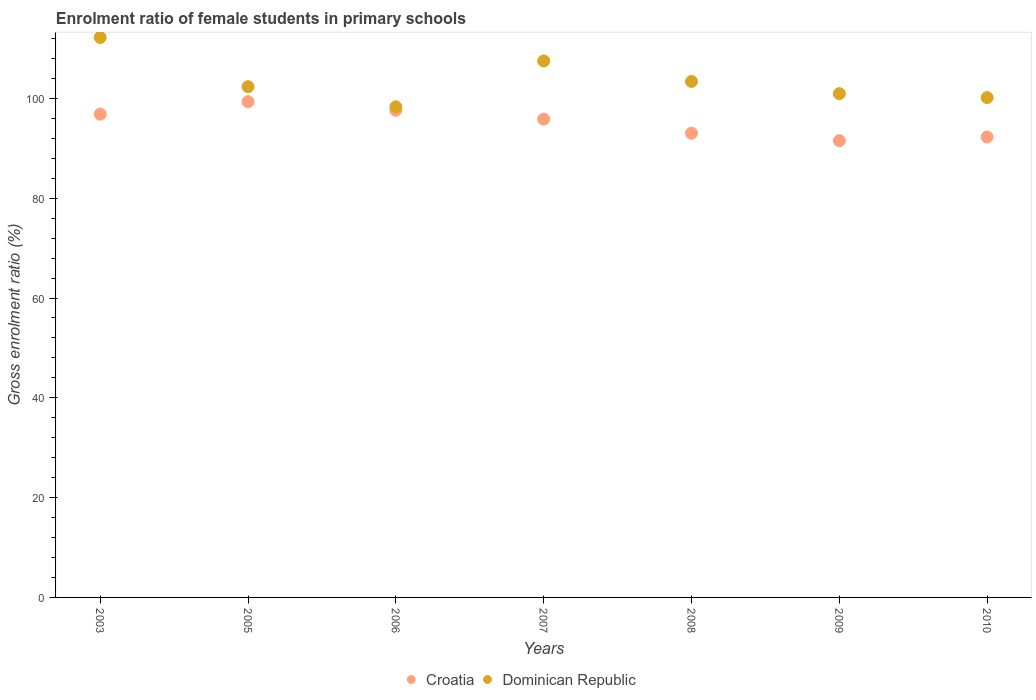Is the number of dotlines equal to the number of legend labels?
Keep it short and to the point. Yes. What is the enrolment ratio of female students in primary schools in Croatia in 2005?
Your response must be concise. 99.34. Across all years, what is the maximum enrolment ratio of female students in primary schools in Dominican Republic?
Your answer should be very brief. 112.22. Across all years, what is the minimum enrolment ratio of female students in primary schools in Dominican Republic?
Your response must be concise. 98.31. What is the total enrolment ratio of female students in primary schools in Croatia in the graph?
Provide a succinct answer. 666.46. What is the difference between the enrolment ratio of female students in primary schools in Dominican Republic in 2006 and that in 2009?
Your response must be concise. -2.64. What is the difference between the enrolment ratio of female students in primary schools in Dominican Republic in 2006 and the enrolment ratio of female students in primary schools in Croatia in 2008?
Make the answer very short. 5.29. What is the average enrolment ratio of female students in primary schools in Dominican Republic per year?
Provide a short and direct response. 103.55. In the year 2007, what is the difference between the enrolment ratio of female students in primary schools in Dominican Republic and enrolment ratio of female students in primary schools in Croatia?
Provide a succinct answer. 11.66. What is the ratio of the enrolment ratio of female students in primary schools in Dominican Republic in 2005 to that in 2006?
Your answer should be compact. 1.04. What is the difference between the highest and the second highest enrolment ratio of female students in primary schools in Croatia?
Give a very brief answer. 1.73. What is the difference between the highest and the lowest enrolment ratio of female students in primary schools in Dominican Republic?
Keep it short and to the point. 13.91. Is the sum of the enrolment ratio of female students in primary schools in Dominican Republic in 2003 and 2006 greater than the maximum enrolment ratio of female students in primary schools in Croatia across all years?
Provide a short and direct response. Yes. Is the enrolment ratio of female students in primary schools in Croatia strictly greater than the enrolment ratio of female students in primary schools in Dominican Republic over the years?
Give a very brief answer. No. Is the enrolment ratio of female students in primary schools in Croatia strictly less than the enrolment ratio of female students in primary schools in Dominican Republic over the years?
Your response must be concise. Yes. How many dotlines are there?
Your response must be concise. 2. Are the values on the major ticks of Y-axis written in scientific E-notation?
Ensure brevity in your answer.  No. Does the graph contain grids?
Provide a short and direct response. No. Where does the legend appear in the graph?
Offer a very short reply. Bottom center. What is the title of the graph?
Provide a succinct answer. Enrolment ratio of female students in primary schools. Does "West Bank and Gaza" appear as one of the legend labels in the graph?
Ensure brevity in your answer.  No. What is the Gross enrolment ratio (%) in Croatia in 2003?
Keep it short and to the point. 96.85. What is the Gross enrolment ratio (%) in Dominican Republic in 2003?
Provide a succinct answer. 112.22. What is the Gross enrolment ratio (%) of Croatia in 2005?
Offer a terse response. 99.34. What is the Gross enrolment ratio (%) of Dominican Republic in 2005?
Make the answer very short. 102.34. What is the Gross enrolment ratio (%) of Croatia in 2006?
Keep it short and to the point. 97.62. What is the Gross enrolment ratio (%) in Dominican Republic in 2006?
Give a very brief answer. 98.31. What is the Gross enrolment ratio (%) in Croatia in 2007?
Your answer should be compact. 95.84. What is the Gross enrolment ratio (%) in Dominican Republic in 2007?
Your answer should be very brief. 107.5. What is the Gross enrolment ratio (%) in Croatia in 2008?
Keep it short and to the point. 93.02. What is the Gross enrolment ratio (%) in Dominican Republic in 2008?
Ensure brevity in your answer.  103.39. What is the Gross enrolment ratio (%) in Croatia in 2009?
Provide a succinct answer. 91.52. What is the Gross enrolment ratio (%) of Dominican Republic in 2009?
Offer a very short reply. 100.95. What is the Gross enrolment ratio (%) in Croatia in 2010?
Your answer should be very brief. 92.26. What is the Gross enrolment ratio (%) in Dominican Republic in 2010?
Offer a very short reply. 100.16. Across all years, what is the maximum Gross enrolment ratio (%) in Croatia?
Provide a succinct answer. 99.34. Across all years, what is the maximum Gross enrolment ratio (%) in Dominican Republic?
Offer a very short reply. 112.22. Across all years, what is the minimum Gross enrolment ratio (%) of Croatia?
Give a very brief answer. 91.52. Across all years, what is the minimum Gross enrolment ratio (%) in Dominican Republic?
Keep it short and to the point. 98.31. What is the total Gross enrolment ratio (%) in Croatia in the graph?
Provide a succinct answer. 666.46. What is the total Gross enrolment ratio (%) in Dominican Republic in the graph?
Provide a succinct answer. 724.87. What is the difference between the Gross enrolment ratio (%) of Croatia in 2003 and that in 2005?
Give a very brief answer. -2.5. What is the difference between the Gross enrolment ratio (%) in Dominican Republic in 2003 and that in 2005?
Make the answer very short. 9.87. What is the difference between the Gross enrolment ratio (%) in Croatia in 2003 and that in 2006?
Your answer should be very brief. -0.77. What is the difference between the Gross enrolment ratio (%) in Dominican Republic in 2003 and that in 2006?
Keep it short and to the point. 13.91. What is the difference between the Gross enrolment ratio (%) of Croatia in 2003 and that in 2007?
Provide a short and direct response. 1. What is the difference between the Gross enrolment ratio (%) of Dominican Republic in 2003 and that in 2007?
Your response must be concise. 4.71. What is the difference between the Gross enrolment ratio (%) of Croatia in 2003 and that in 2008?
Your answer should be very brief. 3.82. What is the difference between the Gross enrolment ratio (%) of Dominican Republic in 2003 and that in 2008?
Give a very brief answer. 8.83. What is the difference between the Gross enrolment ratio (%) in Croatia in 2003 and that in 2009?
Give a very brief answer. 5.32. What is the difference between the Gross enrolment ratio (%) of Dominican Republic in 2003 and that in 2009?
Your answer should be very brief. 11.27. What is the difference between the Gross enrolment ratio (%) in Croatia in 2003 and that in 2010?
Your response must be concise. 4.58. What is the difference between the Gross enrolment ratio (%) in Dominican Republic in 2003 and that in 2010?
Your answer should be compact. 12.06. What is the difference between the Gross enrolment ratio (%) in Croatia in 2005 and that in 2006?
Offer a terse response. 1.73. What is the difference between the Gross enrolment ratio (%) of Dominican Republic in 2005 and that in 2006?
Make the answer very short. 4.04. What is the difference between the Gross enrolment ratio (%) of Croatia in 2005 and that in 2007?
Give a very brief answer. 3.5. What is the difference between the Gross enrolment ratio (%) in Dominican Republic in 2005 and that in 2007?
Provide a short and direct response. -5.16. What is the difference between the Gross enrolment ratio (%) of Croatia in 2005 and that in 2008?
Keep it short and to the point. 6.32. What is the difference between the Gross enrolment ratio (%) of Dominican Republic in 2005 and that in 2008?
Give a very brief answer. -1.04. What is the difference between the Gross enrolment ratio (%) of Croatia in 2005 and that in 2009?
Keep it short and to the point. 7.82. What is the difference between the Gross enrolment ratio (%) of Dominican Republic in 2005 and that in 2009?
Ensure brevity in your answer.  1.4. What is the difference between the Gross enrolment ratio (%) of Croatia in 2005 and that in 2010?
Keep it short and to the point. 7.08. What is the difference between the Gross enrolment ratio (%) in Dominican Republic in 2005 and that in 2010?
Offer a very short reply. 2.18. What is the difference between the Gross enrolment ratio (%) in Croatia in 2006 and that in 2007?
Provide a short and direct response. 1.77. What is the difference between the Gross enrolment ratio (%) of Dominican Republic in 2006 and that in 2007?
Make the answer very short. -9.2. What is the difference between the Gross enrolment ratio (%) in Croatia in 2006 and that in 2008?
Your answer should be compact. 4.6. What is the difference between the Gross enrolment ratio (%) of Dominican Republic in 2006 and that in 2008?
Your response must be concise. -5.08. What is the difference between the Gross enrolment ratio (%) of Croatia in 2006 and that in 2009?
Your response must be concise. 6.1. What is the difference between the Gross enrolment ratio (%) of Dominican Republic in 2006 and that in 2009?
Provide a succinct answer. -2.64. What is the difference between the Gross enrolment ratio (%) in Croatia in 2006 and that in 2010?
Offer a very short reply. 5.36. What is the difference between the Gross enrolment ratio (%) of Dominican Republic in 2006 and that in 2010?
Provide a succinct answer. -1.85. What is the difference between the Gross enrolment ratio (%) of Croatia in 2007 and that in 2008?
Your answer should be very brief. 2.82. What is the difference between the Gross enrolment ratio (%) of Dominican Republic in 2007 and that in 2008?
Provide a short and direct response. 4.11. What is the difference between the Gross enrolment ratio (%) in Croatia in 2007 and that in 2009?
Make the answer very short. 4.32. What is the difference between the Gross enrolment ratio (%) in Dominican Republic in 2007 and that in 2009?
Make the answer very short. 6.56. What is the difference between the Gross enrolment ratio (%) of Croatia in 2007 and that in 2010?
Keep it short and to the point. 3.58. What is the difference between the Gross enrolment ratio (%) in Dominican Republic in 2007 and that in 2010?
Make the answer very short. 7.34. What is the difference between the Gross enrolment ratio (%) of Croatia in 2008 and that in 2009?
Your answer should be very brief. 1.5. What is the difference between the Gross enrolment ratio (%) of Dominican Republic in 2008 and that in 2009?
Ensure brevity in your answer.  2.44. What is the difference between the Gross enrolment ratio (%) of Croatia in 2008 and that in 2010?
Your answer should be very brief. 0.76. What is the difference between the Gross enrolment ratio (%) in Dominican Republic in 2008 and that in 2010?
Ensure brevity in your answer.  3.23. What is the difference between the Gross enrolment ratio (%) in Croatia in 2009 and that in 2010?
Your response must be concise. -0.74. What is the difference between the Gross enrolment ratio (%) of Dominican Republic in 2009 and that in 2010?
Keep it short and to the point. 0.79. What is the difference between the Gross enrolment ratio (%) in Croatia in 2003 and the Gross enrolment ratio (%) in Dominican Republic in 2005?
Your answer should be very brief. -5.5. What is the difference between the Gross enrolment ratio (%) in Croatia in 2003 and the Gross enrolment ratio (%) in Dominican Republic in 2006?
Keep it short and to the point. -1.46. What is the difference between the Gross enrolment ratio (%) of Croatia in 2003 and the Gross enrolment ratio (%) of Dominican Republic in 2007?
Offer a very short reply. -10.66. What is the difference between the Gross enrolment ratio (%) of Croatia in 2003 and the Gross enrolment ratio (%) of Dominican Republic in 2008?
Give a very brief answer. -6.54. What is the difference between the Gross enrolment ratio (%) in Croatia in 2003 and the Gross enrolment ratio (%) in Dominican Republic in 2009?
Your answer should be very brief. -4.1. What is the difference between the Gross enrolment ratio (%) in Croatia in 2003 and the Gross enrolment ratio (%) in Dominican Republic in 2010?
Provide a succinct answer. -3.31. What is the difference between the Gross enrolment ratio (%) of Croatia in 2005 and the Gross enrolment ratio (%) of Dominican Republic in 2006?
Your answer should be very brief. 1.04. What is the difference between the Gross enrolment ratio (%) of Croatia in 2005 and the Gross enrolment ratio (%) of Dominican Republic in 2007?
Ensure brevity in your answer.  -8.16. What is the difference between the Gross enrolment ratio (%) of Croatia in 2005 and the Gross enrolment ratio (%) of Dominican Republic in 2008?
Keep it short and to the point. -4.04. What is the difference between the Gross enrolment ratio (%) of Croatia in 2005 and the Gross enrolment ratio (%) of Dominican Republic in 2009?
Your answer should be very brief. -1.6. What is the difference between the Gross enrolment ratio (%) in Croatia in 2005 and the Gross enrolment ratio (%) in Dominican Republic in 2010?
Give a very brief answer. -0.82. What is the difference between the Gross enrolment ratio (%) of Croatia in 2006 and the Gross enrolment ratio (%) of Dominican Republic in 2007?
Keep it short and to the point. -9.88. What is the difference between the Gross enrolment ratio (%) in Croatia in 2006 and the Gross enrolment ratio (%) in Dominican Republic in 2008?
Your answer should be compact. -5.77. What is the difference between the Gross enrolment ratio (%) in Croatia in 2006 and the Gross enrolment ratio (%) in Dominican Republic in 2009?
Give a very brief answer. -3.33. What is the difference between the Gross enrolment ratio (%) in Croatia in 2006 and the Gross enrolment ratio (%) in Dominican Republic in 2010?
Offer a terse response. -2.54. What is the difference between the Gross enrolment ratio (%) of Croatia in 2007 and the Gross enrolment ratio (%) of Dominican Republic in 2008?
Keep it short and to the point. -7.54. What is the difference between the Gross enrolment ratio (%) in Croatia in 2007 and the Gross enrolment ratio (%) in Dominican Republic in 2009?
Your answer should be very brief. -5.1. What is the difference between the Gross enrolment ratio (%) in Croatia in 2007 and the Gross enrolment ratio (%) in Dominican Republic in 2010?
Make the answer very short. -4.31. What is the difference between the Gross enrolment ratio (%) in Croatia in 2008 and the Gross enrolment ratio (%) in Dominican Republic in 2009?
Your answer should be very brief. -7.93. What is the difference between the Gross enrolment ratio (%) in Croatia in 2008 and the Gross enrolment ratio (%) in Dominican Republic in 2010?
Offer a terse response. -7.14. What is the difference between the Gross enrolment ratio (%) in Croatia in 2009 and the Gross enrolment ratio (%) in Dominican Republic in 2010?
Give a very brief answer. -8.64. What is the average Gross enrolment ratio (%) of Croatia per year?
Provide a succinct answer. 95.21. What is the average Gross enrolment ratio (%) of Dominican Republic per year?
Keep it short and to the point. 103.55. In the year 2003, what is the difference between the Gross enrolment ratio (%) of Croatia and Gross enrolment ratio (%) of Dominican Republic?
Ensure brevity in your answer.  -15.37. In the year 2005, what is the difference between the Gross enrolment ratio (%) in Croatia and Gross enrolment ratio (%) in Dominican Republic?
Your answer should be compact. -3. In the year 2006, what is the difference between the Gross enrolment ratio (%) of Croatia and Gross enrolment ratio (%) of Dominican Republic?
Your response must be concise. -0.69. In the year 2007, what is the difference between the Gross enrolment ratio (%) in Croatia and Gross enrolment ratio (%) in Dominican Republic?
Make the answer very short. -11.66. In the year 2008, what is the difference between the Gross enrolment ratio (%) in Croatia and Gross enrolment ratio (%) in Dominican Republic?
Offer a terse response. -10.37. In the year 2009, what is the difference between the Gross enrolment ratio (%) of Croatia and Gross enrolment ratio (%) of Dominican Republic?
Keep it short and to the point. -9.43. In the year 2010, what is the difference between the Gross enrolment ratio (%) in Croatia and Gross enrolment ratio (%) in Dominican Republic?
Give a very brief answer. -7.9. What is the ratio of the Gross enrolment ratio (%) in Croatia in 2003 to that in 2005?
Your answer should be very brief. 0.97. What is the ratio of the Gross enrolment ratio (%) of Dominican Republic in 2003 to that in 2005?
Your response must be concise. 1.1. What is the ratio of the Gross enrolment ratio (%) of Dominican Republic in 2003 to that in 2006?
Provide a succinct answer. 1.14. What is the ratio of the Gross enrolment ratio (%) in Croatia in 2003 to that in 2007?
Give a very brief answer. 1.01. What is the ratio of the Gross enrolment ratio (%) in Dominican Republic in 2003 to that in 2007?
Give a very brief answer. 1.04. What is the ratio of the Gross enrolment ratio (%) of Croatia in 2003 to that in 2008?
Make the answer very short. 1.04. What is the ratio of the Gross enrolment ratio (%) of Dominican Republic in 2003 to that in 2008?
Ensure brevity in your answer.  1.09. What is the ratio of the Gross enrolment ratio (%) in Croatia in 2003 to that in 2009?
Provide a short and direct response. 1.06. What is the ratio of the Gross enrolment ratio (%) of Dominican Republic in 2003 to that in 2009?
Keep it short and to the point. 1.11. What is the ratio of the Gross enrolment ratio (%) of Croatia in 2003 to that in 2010?
Offer a very short reply. 1.05. What is the ratio of the Gross enrolment ratio (%) of Dominican Republic in 2003 to that in 2010?
Provide a short and direct response. 1.12. What is the ratio of the Gross enrolment ratio (%) of Croatia in 2005 to that in 2006?
Your answer should be compact. 1.02. What is the ratio of the Gross enrolment ratio (%) of Dominican Republic in 2005 to that in 2006?
Keep it short and to the point. 1.04. What is the ratio of the Gross enrolment ratio (%) of Croatia in 2005 to that in 2007?
Ensure brevity in your answer.  1.04. What is the ratio of the Gross enrolment ratio (%) in Dominican Republic in 2005 to that in 2007?
Offer a very short reply. 0.95. What is the ratio of the Gross enrolment ratio (%) of Croatia in 2005 to that in 2008?
Provide a short and direct response. 1.07. What is the ratio of the Gross enrolment ratio (%) of Dominican Republic in 2005 to that in 2008?
Provide a succinct answer. 0.99. What is the ratio of the Gross enrolment ratio (%) in Croatia in 2005 to that in 2009?
Provide a short and direct response. 1.09. What is the ratio of the Gross enrolment ratio (%) of Dominican Republic in 2005 to that in 2009?
Your answer should be compact. 1.01. What is the ratio of the Gross enrolment ratio (%) in Croatia in 2005 to that in 2010?
Give a very brief answer. 1.08. What is the ratio of the Gross enrolment ratio (%) of Dominican Republic in 2005 to that in 2010?
Provide a succinct answer. 1.02. What is the ratio of the Gross enrolment ratio (%) of Croatia in 2006 to that in 2007?
Your answer should be compact. 1.02. What is the ratio of the Gross enrolment ratio (%) of Dominican Republic in 2006 to that in 2007?
Offer a very short reply. 0.91. What is the ratio of the Gross enrolment ratio (%) in Croatia in 2006 to that in 2008?
Make the answer very short. 1.05. What is the ratio of the Gross enrolment ratio (%) of Dominican Republic in 2006 to that in 2008?
Your answer should be compact. 0.95. What is the ratio of the Gross enrolment ratio (%) of Croatia in 2006 to that in 2009?
Provide a short and direct response. 1.07. What is the ratio of the Gross enrolment ratio (%) in Dominican Republic in 2006 to that in 2009?
Provide a short and direct response. 0.97. What is the ratio of the Gross enrolment ratio (%) of Croatia in 2006 to that in 2010?
Keep it short and to the point. 1.06. What is the ratio of the Gross enrolment ratio (%) in Dominican Republic in 2006 to that in 2010?
Your answer should be compact. 0.98. What is the ratio of the Gross enrolment ratio (%) of Croatia in 2007 to that in 2008?
Provide a succinct answer. 1.03. What is the ratio of the Gross enrolment ratio (%) in Dominican Republic in 2007 to that in 2008?
Offer a terse response. 1.04. What is the ratio of the Gross enrolment ratio (%) in Croatia in 2007 to that in 2009?
Your answer should be compact. 1.05. What is the ratio of the Gross enrolment ratio (%) of Dominican Republic in 2007 to that in 2009?
Offer a very short reply. 1.06. What is the ratio of the Gross enrolment ratio (%) of Croatia in 2007 to that in 2010?
Ensure brevity in your answer.  1.04. What is the ratio of the Gross enrolment ratio (%) in Dominican Republic in 2007 to that in 2010?
Make the answer very short. 1.07. What is the ratio of the Gross enrolment ratio (%) in Croatia in 2008 to that in 2009?
Keep it short and to the point. 1.02. What is the ratio of the Gross enrolment ratio (%) in Dominican Republic in 2008 to that in 2009?
Keep it short and to the point. 1.02. What is the ratio of the Gross enrolment ratio (%) in Croatia in 2008 to that in 2010?
Your response must be concise. 1.01. What is the ratio of the Gross enrolment ratio (%) in Dominican Republic in 2008 to that in 2010?
Provide a short and direct response. 1.03. What is the ratio of the Gross enrolment ratio (%) of Croatia in 2009 to that in 2010?
Offer a terse response. 0.99. What is the ratio of the Gross enrolment ratio (%) in Dominican Republic in 2009 to that in 2010?
Your answer should be very brief. 1.01. What is the difference between the highest and the second highest Gross enrolment ratio (%) of Croatia?
Keep it short and to the point. 1.73. What is the difference between the highest and the second highest Gross enrolment ratio (%) in Dominican Republic?
Give a very brief answer. 4.71. What is the difference between the highest and the lowest Gross enrolment ratio (%) of Croatia?
Keep it short and to the point. 7.82. What is the difference between the highest and the lowest Gross enrolment ratio (%) of Dominican Republic?
Offer a very short reply. 13.91. 